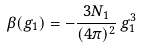Convert formula to latex. <formula><loc_0><loc_0><loc_500><loc_500>\beta ( g _ { 1 } ) = - \frac { 3 N _ { 1 } } { ( 4 \pi ) ^ { 2 } } \, g _ { 1 } ^ { 3 }</formula> 